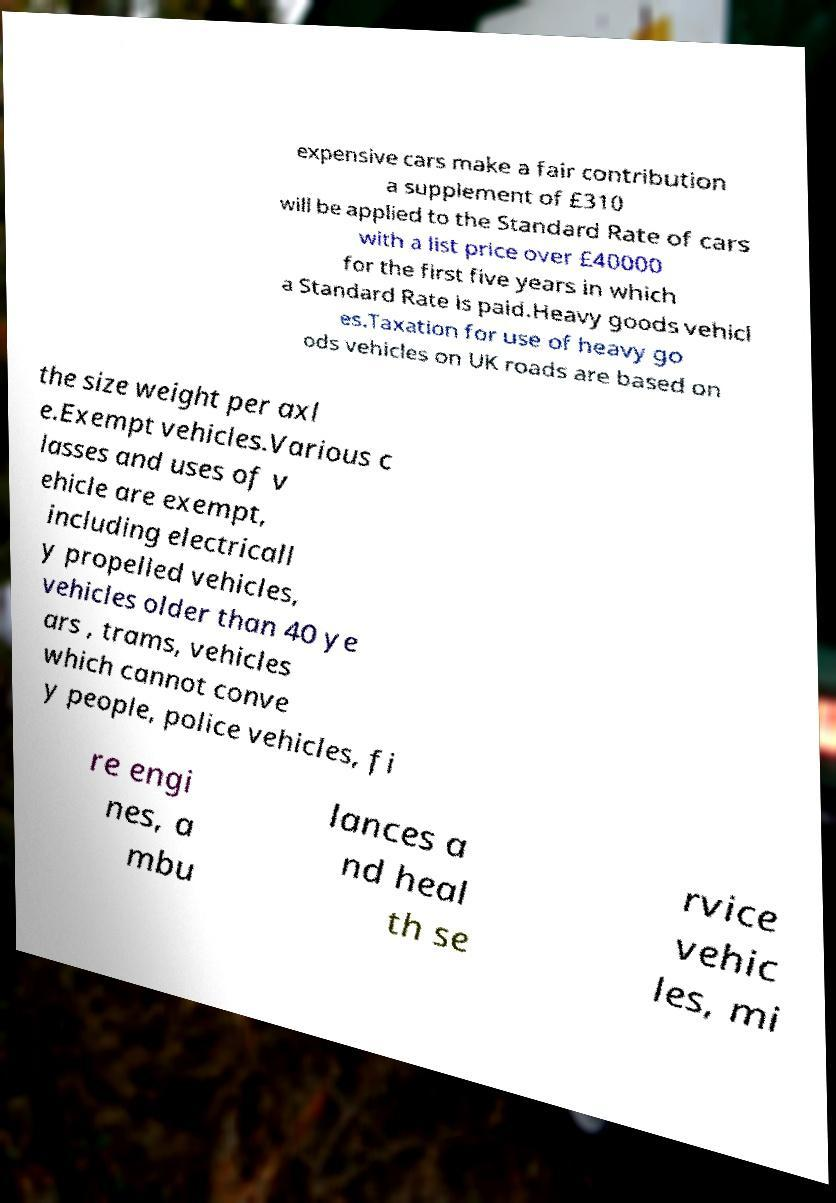There's text embedded in this image that I need extracted. Can you transcribe it verbatim? expensive cars make a fair contribution a supplement of £310 will be applied to the Standard Rate of cars with a list price over £40000 for the first five years in which a Standard Rate is paid.Heavy goods vehicl es.Taxation for use of heavy go ods vehicles on UK roads are based on the size weight per axl e.Exempt vehicles.Various c lasses and uses of v ehicle are exempt, including electricall y propelled vehicles, vehicles older than 40 ye ars , trams, vehicles which cannot conve y people, police vehicles, fi re engi nes, a mbu lances a nd heal th se rvice vehic les, mi 